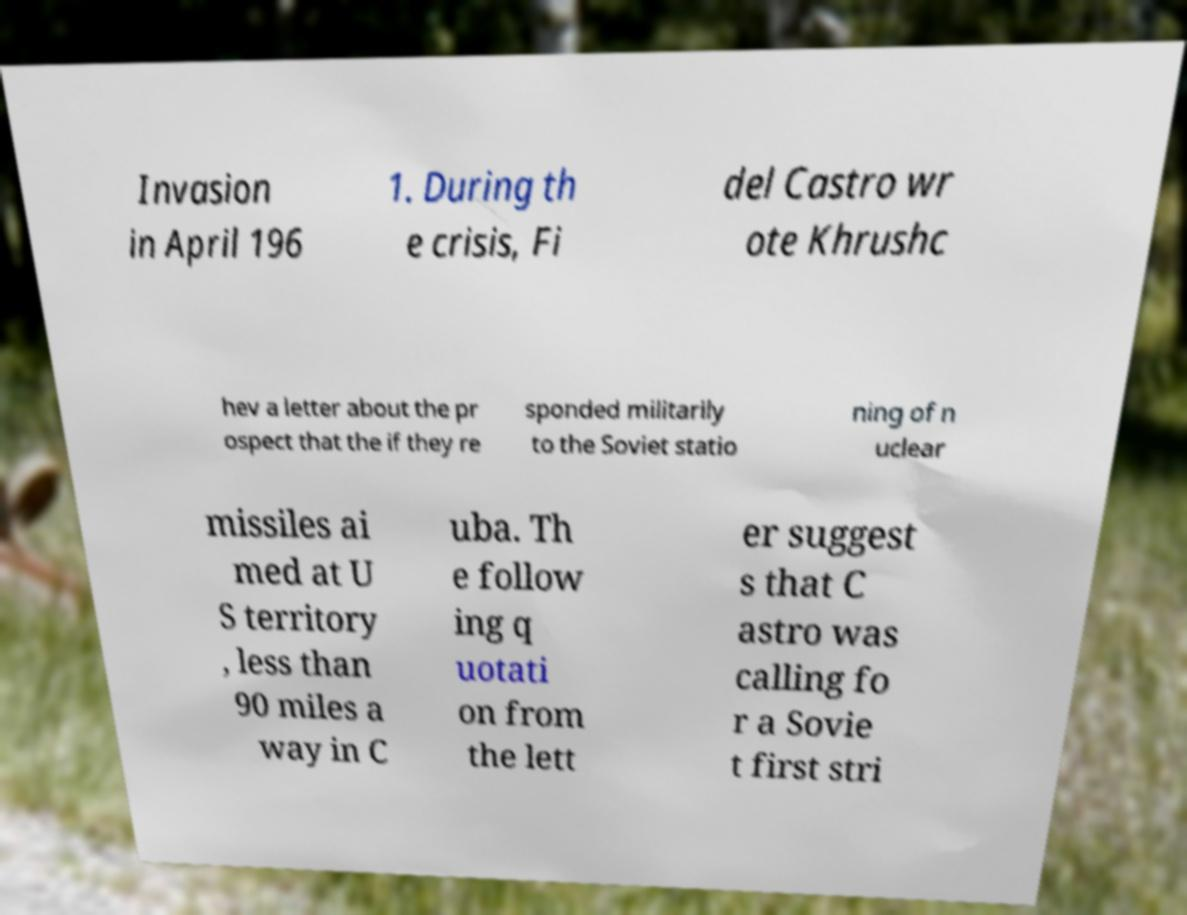Could you extract and type out the text from this image? Invasion in April 196 1. During th e crisis, Fi del Castro wr ote Khrushc hev a letter about the pr ospect that the if they re sponded militarily to the Soviet statio ning of n uclear missiles ai med at U S territory , less than 90 miles a way in C uba. Th e follow ing q uotati on from the lett er suggest s that C astro was calling fo r a Sovie t first stri 